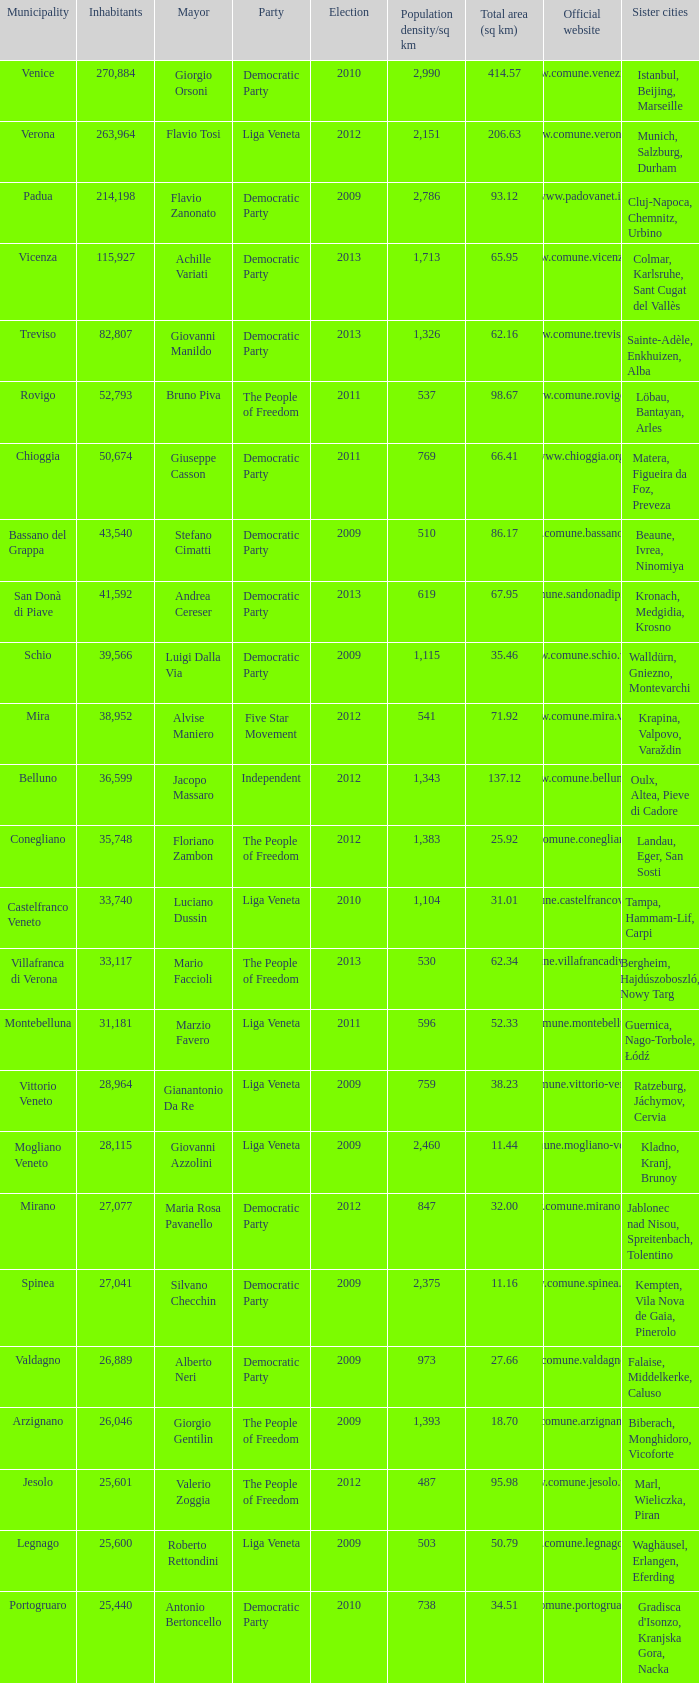How many elections had more than 36,599 inhabitants when Mayor was giovanni manildo? 1.0. 